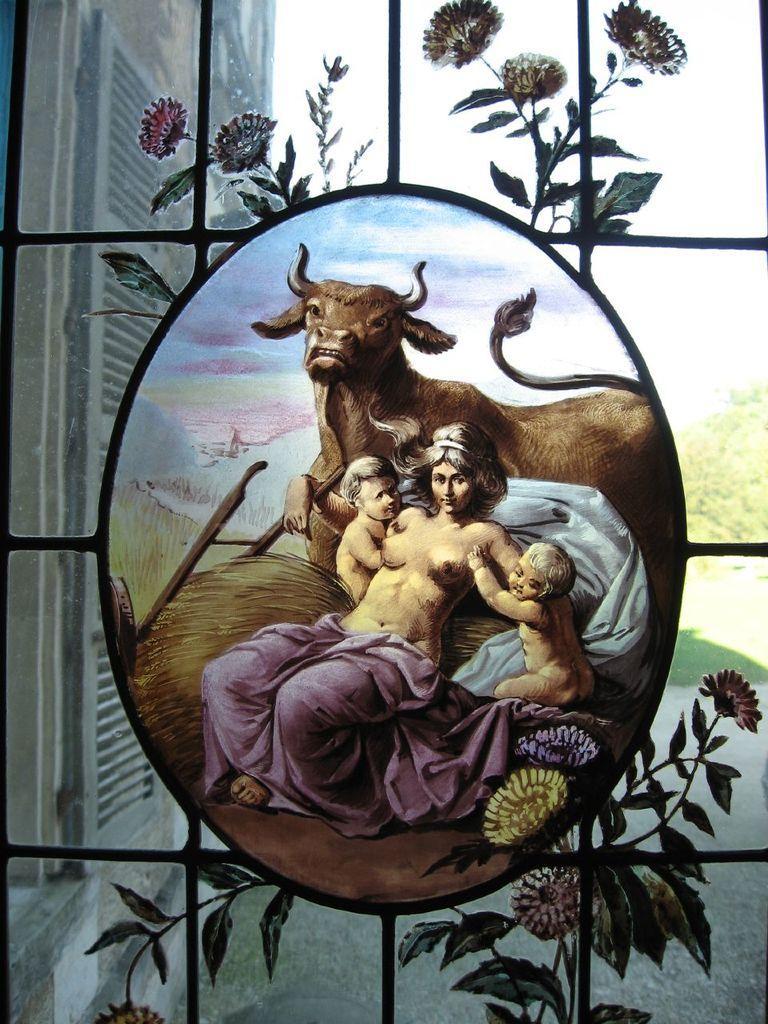How would you summarize this image in a sentence or two? In the middle of the picture, we see a photo frame of a woman, two children and a cow. Behind that, we see a glass window from which we can see the window blind, building, grass, trees and the sky. 